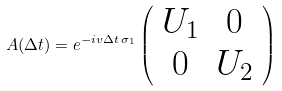<formula> <loc_0><loc_0><loc_500><loc_500>A ( \Delta t ) = e ^ { - i v \Delta t \, \sigma _ { 1 } } \left ( \begin{array} { c c } U _ { 1 } & 0 \\ 0 & U _ { 2 } \end{array} \right )</formula> 